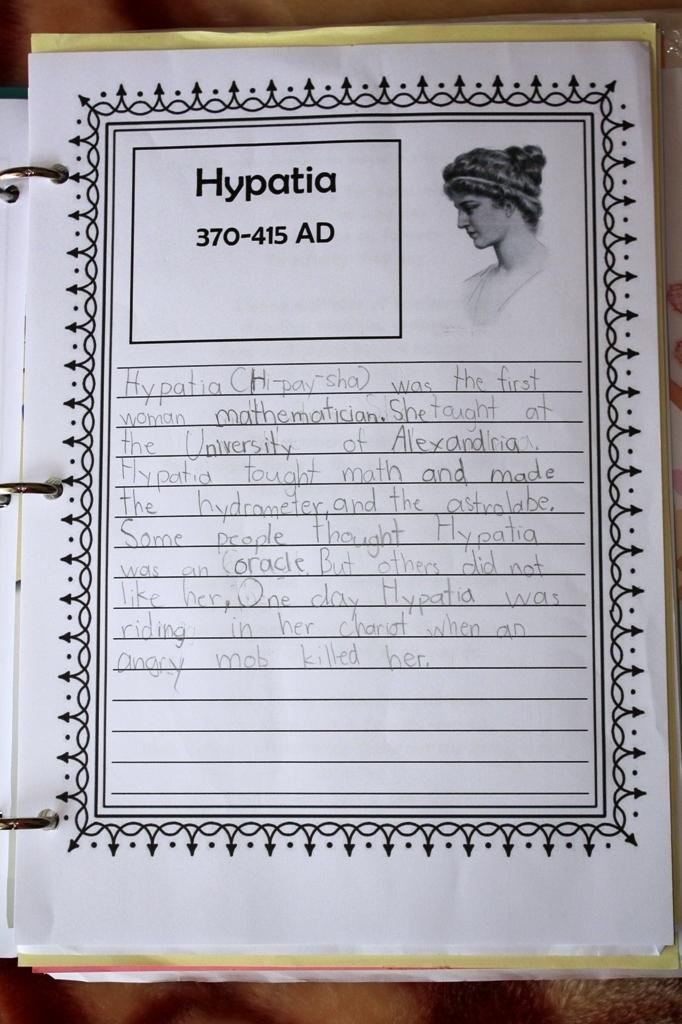What object is present in the image? There is a book in the image. What can be found inside the book? The book contains an image and text. What type of treatment is being offered at the attraction in the image? There is no attraction or treatment present in the image; it only features a book with an image and text. 